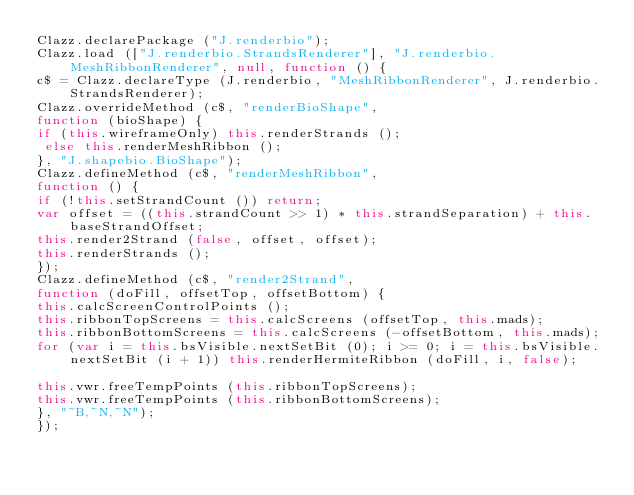<code> <loc_0><loc_0><loc_500><loc_500><_JavaScript_>Clazz.declarePackage ("J.renderbio");
Clazz.load (["J.renderbio.StrandsRenderer"], "J.renderbio.MeshRibbonRenderer", null, function () {
c$ = Clazz.declareType (J.renderbio, "MeshRibbonRenderer", J.renderbio.StrandsRenderer);
Clazz.overrideMethod (c$, "renderBioShape",
function (bioShape) {
if (this.wireframeOnly) this.renderStrands ();
 else this.renderMeshRibbon ();
}, "J.shapebio.BioShape");
Clazz.defineMethod (c$, "renderMeshRibbon",
function () {
if (!this.setStrandCount ()) return;
var offset = ((this.strandCount >> 1) * this.strandSeparation) + this.baseStrandOffset;
this.render2Strand (false, offset, offset);
this.renderStrands ();
});
Clazz.defineMethod (c$, "render2Strand",
function (doFill, offsetTop, offsetBottom) {
this.calcScreenControlPoints ();
this.ribbonTopScreens = this.calcScreens (offsetTop, this.mads);
this.ribbonBottomScreens = this.calcScreens (-offsetBottom, this.mads);
for (var i = this.bsVisible.nextSetBit (0); i >= 0; i = this.bsVisible.nextSetBit (i + 1)) this.renderHermiteRibbon (doFill, i, false);

this.vwr.freeTempPoints (this.ribbonTopScreens);
this.vwr.freeTempPoints (this.ribbonBottomScreens);
}, "~B,~N,~N");
});
</code> 